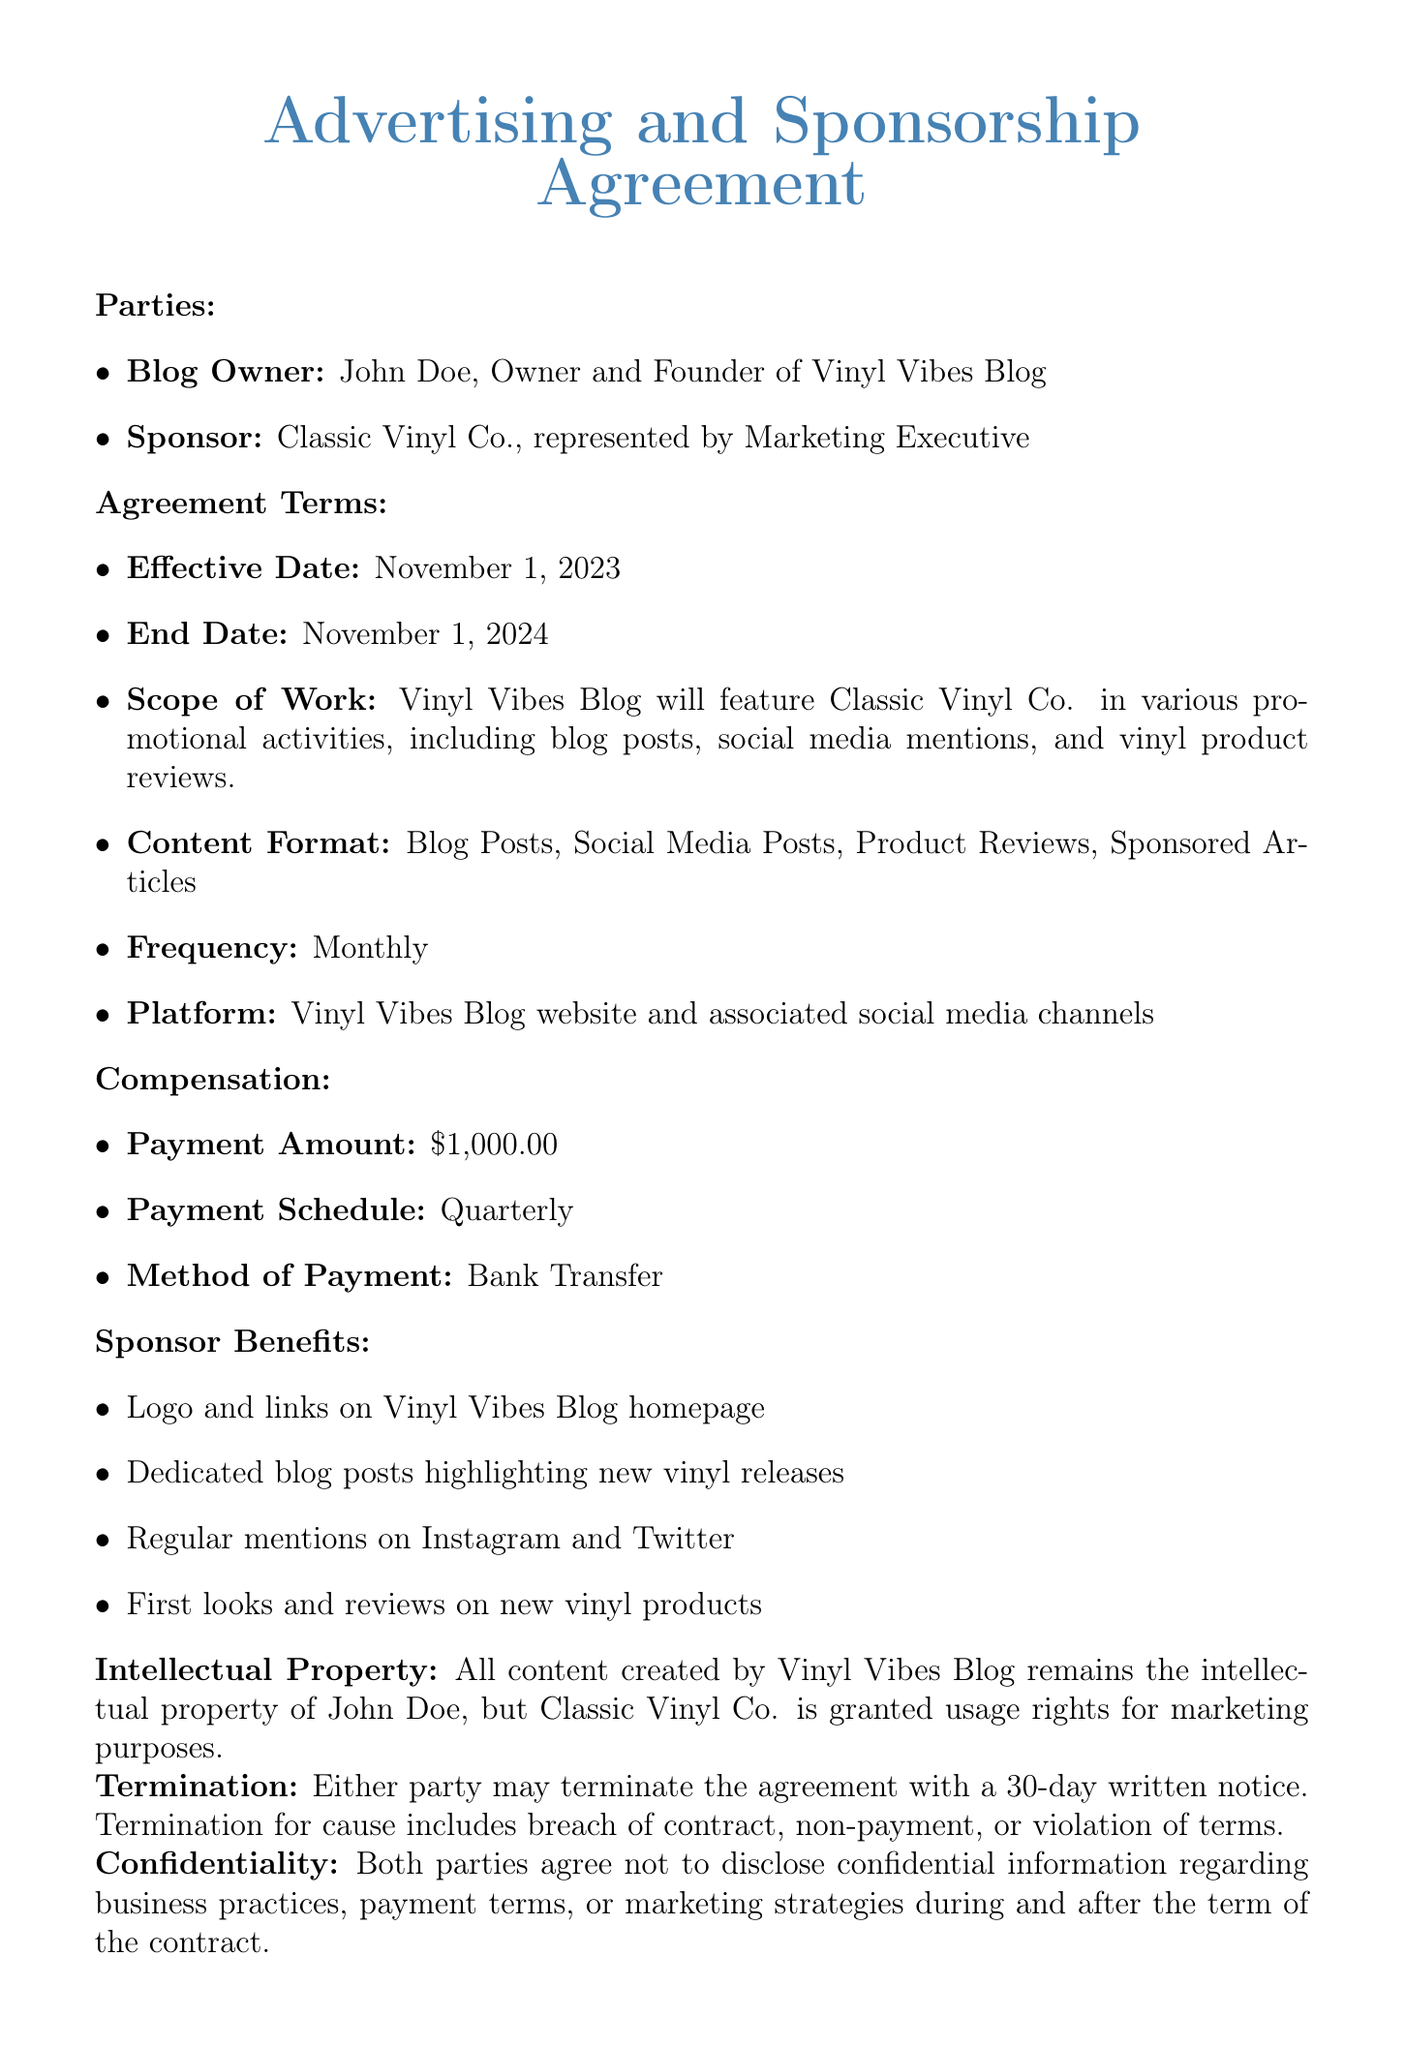What is the effective date of the agreement? The effective date is stated in the agreement terms section and is November 1, 2023.
Answer: November 1, 2023 Who is the blog owner? The blog owner is mentioned in the parties section and is John Doe.
Answer: John Doe What is the payment amount? The payment amount is explicitly listed under the compensation section as $1,000.00.
Answer: $1,000.00 How frequently will content be posted? The frequency of posts is outlined in the agreement and is stated as monthly.
Answer: Monthly What must be given for termination of the agreement? The termination clause specifies a 30-day written notice must be provided.
Answer: 30-day written notice What benefits does the sponsor receive? The document lists benefits such as logo placement and dedicated blog posts, providing insight into sponsor gains.
Answer: Logo and links on Vinyl Vibes Blog homepage What is the governing law for the agreement? The governing law is referenced in the document, which states it is the State of California.
Answer: State of California What happens in case of a breach of contract? The termination section indicates that breaches can result in termination of the contract.
Answer: Termination What is the scope of work mentioned? The scope of work outlines the specific promotional activities that will involve Classic Vinyl Co.
Answer: Promotional activities, including blog posts, social media mentions, and vinyl product reviews 